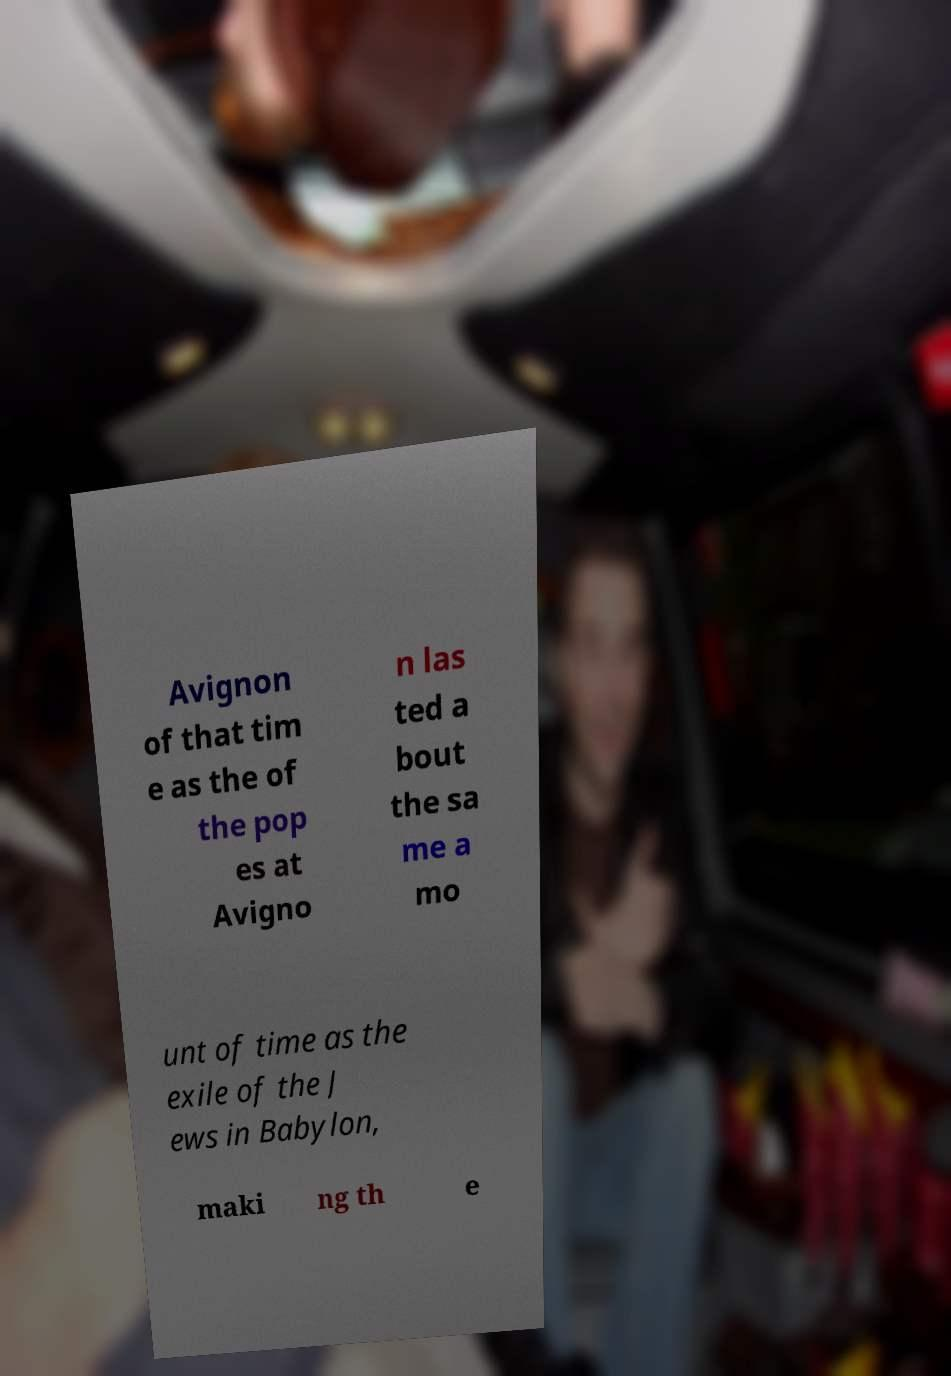What messages or text are displayed in this image? I need them in a readable, typed format. Avignon of that tim e as the of the pop es at Avigno n las ted a bout the sa me a mo unt of time as the exile of the J ews in Babylon, maki ng th e 